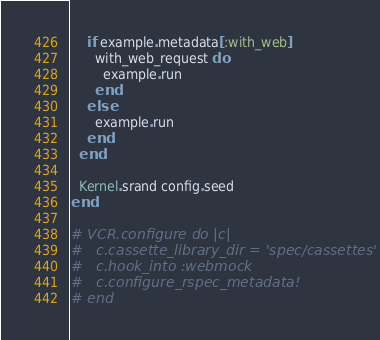<code> <loc_0><loc_0><loc_500><loc_500><_Ruby_>    if example.metadata[:with_web]
      with_web_request do
        example.run
      end
    else
      example.run
    end
  end

  Kernel.srand config.seed
end

# VCR.configure do |c|
#   c.cassette_library_dir = 'spec/cassettes'
#   c.hook_into :webmock
#   c.configure_rspec_metadata!
# end
</code> 